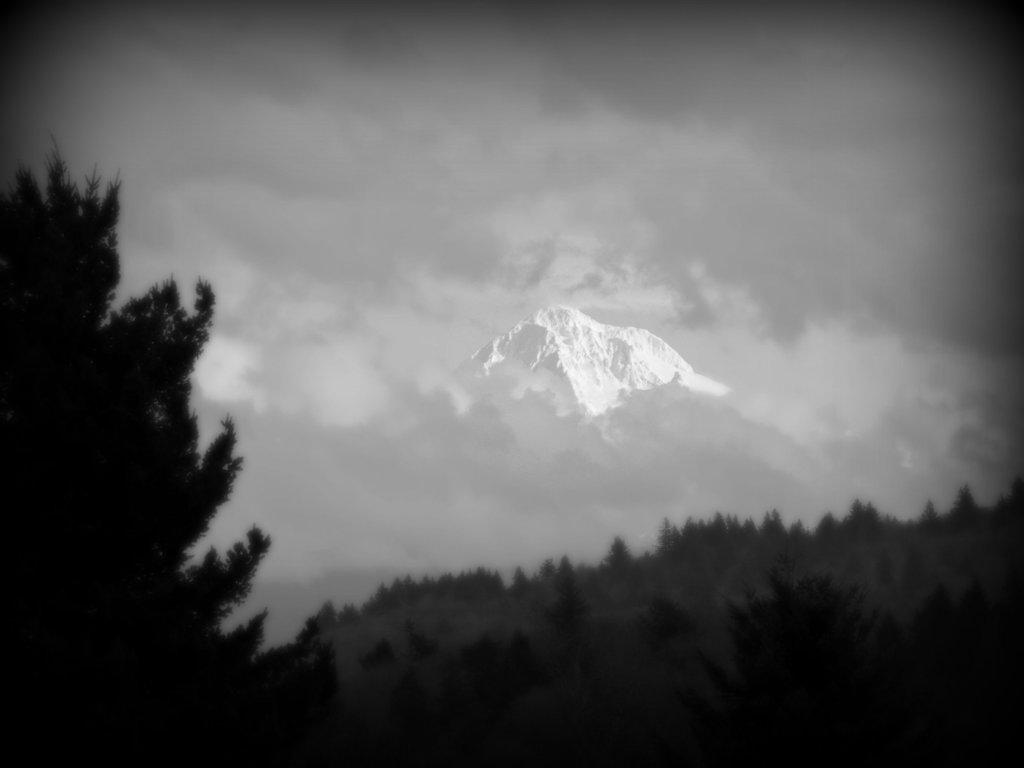What type of natural features can be seen in the image? There are trees and a mountain in the image. What is the condition of the sky in the image? The sky is cloudy in the image. How many feet are visible in the image? There are no feet present in the image; it features trees, a mountain, and a cloudy sky. What type of support can be seen holding up the trees in the image? There is no visible support for the trees in the image; they are standing on their own. 